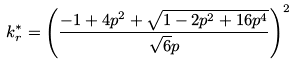Convert formula to latex. <formula><loc_0><loc_0><loc_500><loc_500>k ^ { * } _ { r } = \left ( \frac { - 1 + 4 p ^ { 2 } + \sqrt { 1 - 2 p ^ { 2 } + 1 6 p ^ { 4 } } } { \sqrt { 6 } p } \right ) ^ { 2 }</formula> 